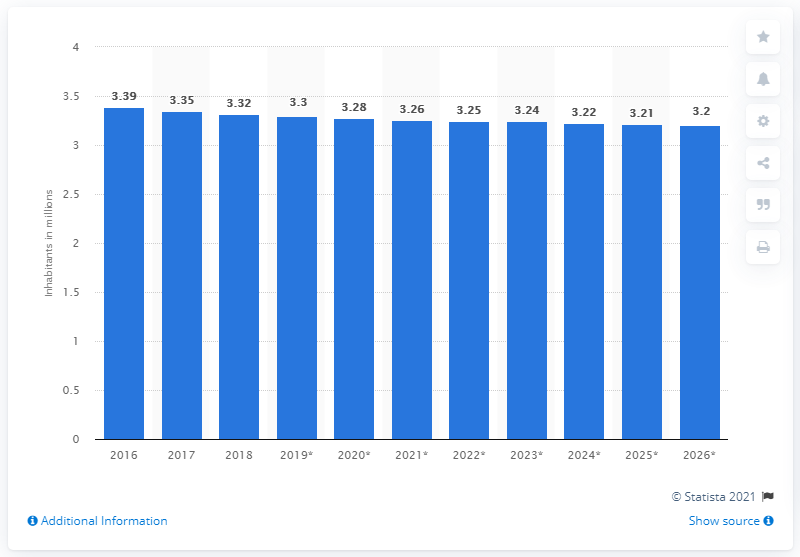Give some essential details in this illustration. The population of Bosnia & Herzegovina in 2018 was approximately 3.3 million. 